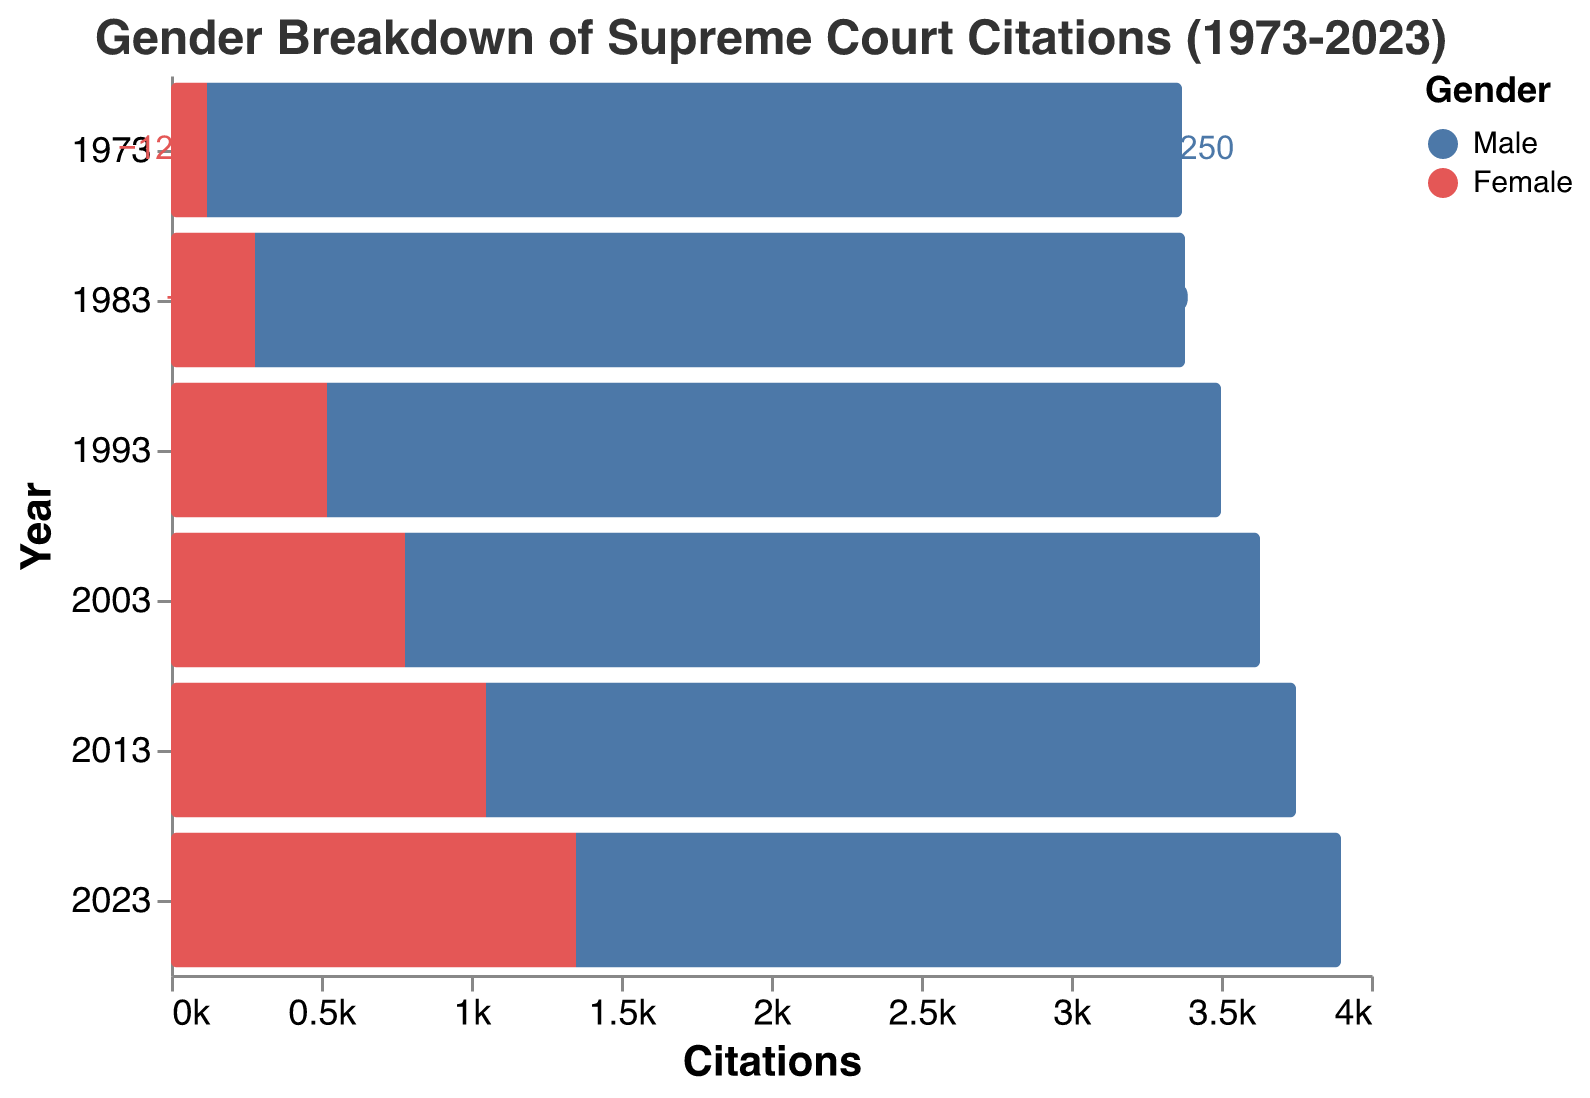What is the title of the figure? The title of the figure is located at the top and it summarizes the content of the visualization. By reading it, we understand that the figure depicts the "Gender Breakdown of Supreme Court Citations (1973-2023)"
Answer: Gender Breakdown of Supreme Court Citations (1973-2023) Which gender had more citations in 1973? To determine the gender with more citations in 1973, we look at the bars corresponding to the year 1973. The male bar is much longer than the female bar.
Answer: Male By how much did female citations increase from 1973 to 2023? To find the increase, subtract the number of citations in 1973 from the number in 2023. The female citations in 1973 were 120, and in 2023 they were 1350. The increase is 1350 - 120 = 1230.
Answer: 1230 What was the trend in male citations from 1973 to 2023? Examine the length of the male bars across the years. The male citations consistently decrease from 3250 in 1973 to 2550 in 2023, indicating a decreasing trend.
Answer: Decreasing What was the difference between male and female citations in 2013? In 2013, male citations were 2700, and female citations were 1050. The difference is 2700 - 1050 = 1650.
Answer: 1650 Which year saw the highest number of female citations? Compare the length of the female bars across all years. The longest female bar is in 2023 with 1350 citations.
Answer: 2023 By how much did male citations decrease from 1983 to 2003? Male citations in 1983 were 3100 and in 2003 were 2850. The decrease is 3100 - 2850 = 250.
Answer: 250 Was there any year when female citations were more than 1000? If yes, which year(s)? Examining the female bars, we see that in 2013 and 2023, female citations were 1050 and 1350, respectively, both of which are more than 1000.
Answer: 2013 and 2023 What is the overall trend in female citations from 1973 to 2023? Look at the length of the female bars over the years. The citations for females have consistently increased from 120 in 1973 to 1350 in 2023.
Answer: Increasing 